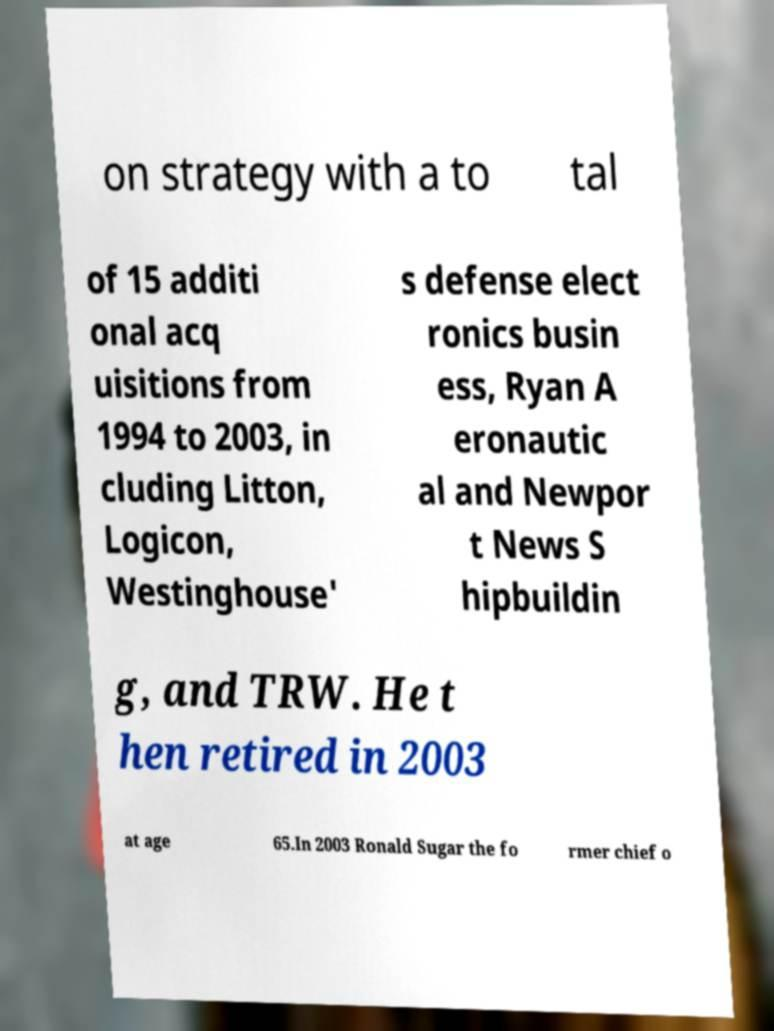Could you extract and type out the text from this image? on strategy with a to tal of 15 additi onal acq uisitions from 1994 to 2003, in cluding Litton, Logicon, Westinghouse' s defense elect ronics busin ess, Ryan A eronautic al and Newpor t News S hipbuildin g, and TRW. He t hen retired in 2003 at age 65.In 2003 Ronald Sugar the fo rmer chief o 